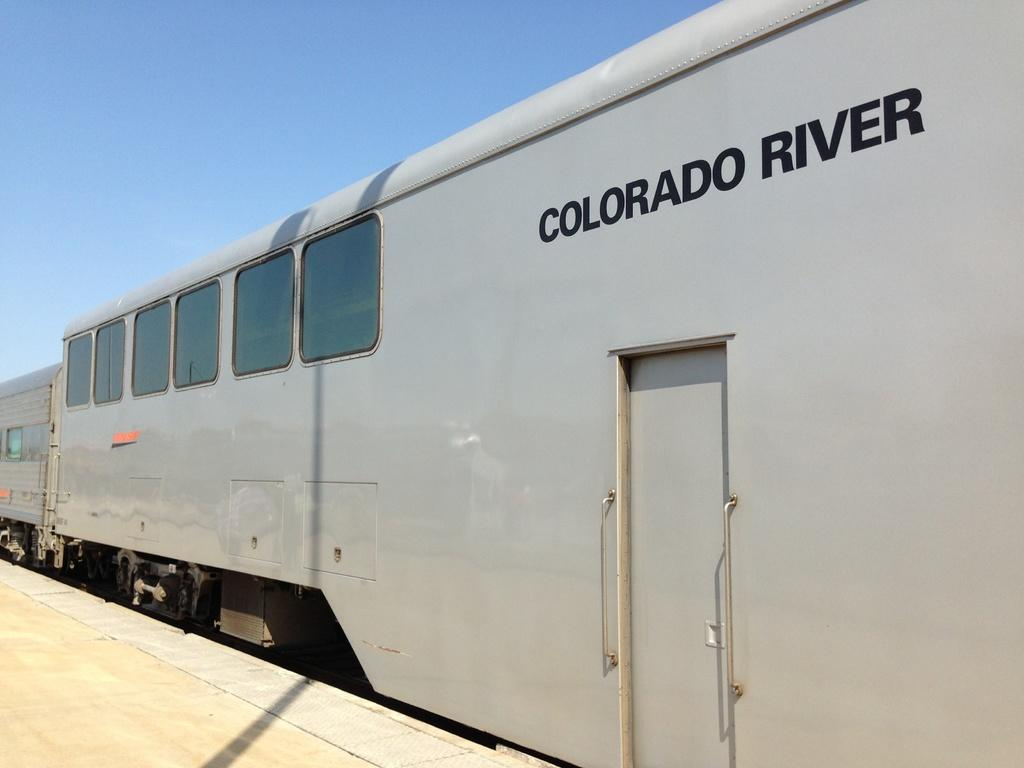What is the main subject of the image? The main subject of the image is a train. Can you describe any specific features of the train? Yes, there is text on the train. How many passengers are on the train in the image? There is no information about passengers in the image, as it only shows the train and text on it. 